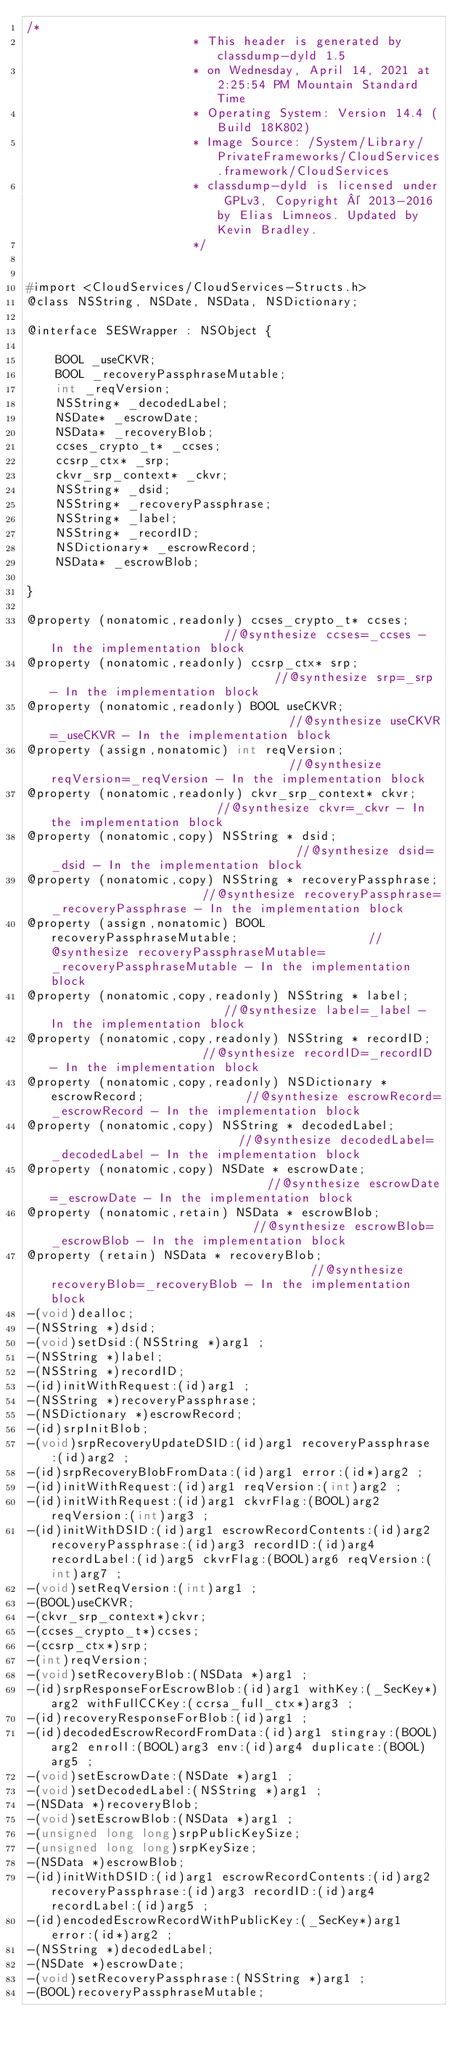<code> <loc_0><loc_0><loc_500><loc_500><_C_>/*
                       * This header is generated by classdump-dyld 1.5
                       * on Wednesday, April 14, 2021 at 2:25:54 PM Mountain Standard Time
                       * Operating System: Version 14.4 (Build 18K802)
                       * Image Source: /System/Library/PrivateFrameworks/CloudServices.framework/CloudServices
                       * classdump-dyld is licensed under GPLv3, Copyright © 2013-2016 by Elias Limneos. Updated by Kevin Bradley.
                       */


#import <CloudServices/CloudServices-Structs.h>
@class NSString, NSDate, NSData, NSDictionary;

@interface SESWrapper : NSObject {

	BOOL _useCKVR;
	BOOL _recoveryPassphraseMutable;
	int _reqVersion;
	NSString* _decodedLabel;
	NSDate* _escrowDate;
	NSData* _recoveryBlob;
	ccses_crypto_t* _ccses;
	ccsrp_ctx* _srp;
	ckvr_srp_context* _ckvr;
	NSString* _dsid;
	NSString* _recoveryPassphrase;
	NSString* _label;
	NSString* _recordID;
	NSDictionary* _escrowRecord;
	NSData* _escrowBlob;

}

@property (nonatomic,readonly) ccses_crypto_t* ccses;                         //@synthesize ccses=_ccses - In the implementation block
@property (nonatomic,readonly) ccsrp_ctx* srp;                                //@synthesize srp=_srp - In the implementation block
@property (nonatomic,readonly) BOOL useCKVR;                                  //@synthesize useCKVR=_useCKVR - In the implementation block
@property (assign,nonatomic) int reqVersion;                                  //@synthesize reqVersion=_reqVersion - In the implementation block
@property (nonatomic,readonly) ckvr_srp_context* ckvr;                        //@synthesize ckvr=_ckvr - In the implementation block
@property (nonatomic,copy) NSString * dsid;                                   //@synthesize dsid=_dsid - In the implementation block
@property (nonatomic,copy) NSString * recoveryPassphrase;                     //@synthesize recoveryPassphrase=_recoveryPassphrase - In the implementation block
@property (assign,nonatomic) BOOL recoveryPassphraseMutable;                  //@synthesize recoveryPassphraseMutable=_recoveryPassphraseMutable - In the implementation block
@property (nonatomic,copy,readonly) NSString * label;                         //@synthesize label=_label - In the implementation block
@property (nonatomic,copy,readonly) NSString * recordID;                      //@synthesize recordID=_recordID - In the implementation block
@property (nonatomic,copy,readonly) NSDictionary * escrowRecord;              //@synthesize escrowRecord=_escrowRecord - In the implementation block
@property (nonatomic,copy) NSString * decodedLabel;                           //@synthesize decodedLabel=_decodedLabel - In the implementation block
@property (nonatomic,copy) NSDate * escrowDate;                               //@synthesize escrowDate=_escrowDate - In the implementation block
@property (nonatomic,retain) NSData * escrowBlob;                             //@synthesize escrowBlob=_escrowBlob - In the implementation block
@property (retain) NSData * recoveryBlob;                                     //@synthesize recoveryBlob=_recoveryBlob - In the implementation block
-(void)dealloc;
-(NSString *)dsid;
-(void)setDsid:(NSString *)arg1 ;
-(NSString *)label;
-(NSString *)recordID;
-(id)initWithRequest:(id)arg1 ;
-(NSString *)recoveryPassphrase;
-(NSDictionary *)escrowRecord;
-(id)srpInitBlob;
-(void)srpRecoveryUpdateDSID:(id)arg1 recoveryPassphrase:(id)arg2 ;
-(id)srpRecoveryBlobFromData:(id)arg1 error:(id*)arg2 ;
-(id)initWithRequest:(id)arg1 reqVersion:(int)arg2 ;
-(id)initWithRequest:(id)arg1 ckvrFlag:(BOOL)arg2 reqVersion:(int)arg3 ;
-(id)initWithDSID:(id)arg1 escrowRecordContents:(id)arg2 recoveryPassphrase:(id)arg3 recordID:(id)arg4 recordLabel:(id)arg5 ckvrFlag:(BOOL)arg6 reqVersion:(int)arg7 ;
-(void)setReqVersion:(int)arg1 ;
-(BOOL)useCKVR;
-(ckvr_srp_context*)ckvr;
-(ccses_crypto_t*)ccses;
-(ccsrp_ctx*)srp;
-(int)reqVersion;
-(void)setRecoveryBlob:(NSData *)arg1 ;
-(id)srpResponseForEscrowBlob:(id)arg1 withKey:(_SecKey*)arg2 withFullCCKey:(ccrsa_full_ctx*)arg3 ;
-(id)recoveryResponseForBlob:(id)arg1 ;
-(id)decodedEscrowRecordFromData:(id)arg1 stingray:(BOOL)arg2 enroll:(BOOL)arg3 env:(id)arg4 duplicate:(BOOL)arg5 ;
-(void)setEscrowDate:(NSDate *)arg1 ;
-(void)setDecodedLabel:(NSString *)arg1 ;
-(NSData *)recoveryBlob;
-(void)setEscrowBlob:(NSData *)arg1 ;
-(unsigned long long)srpPublicKeySize;
-(unsigned long long)srpKeySize;
-(NSData *)escrowBlob;
-(id)initWithDSID:(id)arg1 escrowRecordContents:(id)arg2 recoveryPassphrase:(id)arg3 recordID:(id)arg4 recordLabel:(id)arg5 ;
-(id)encodedEscrowRecordWithPublicKey:(_SecKey*)arg1 error:(id*)arg2 ;
-(NSString *)decodedLabel;
-(NSDate *)escrowDate;
-(void)setRecoveryPassphrase:(NSString *)arg1 ;
-(BOOL)recoveryPassphraseMutable;</code> 